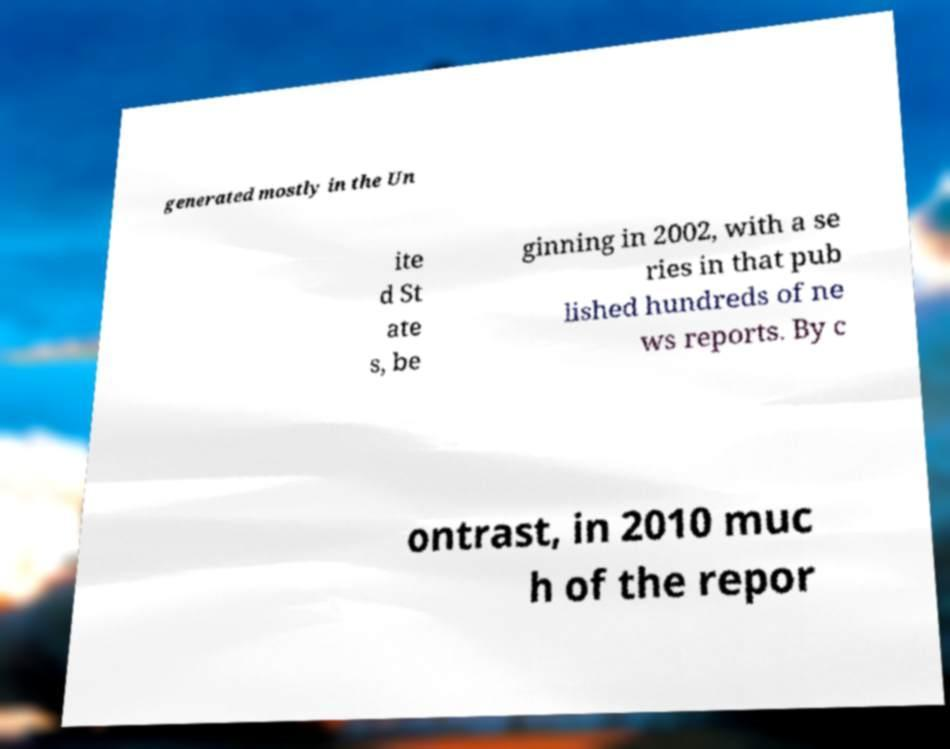Can you accurately transcribe the text from the provided image for me? generated mostly in the Un ite d St ate s, be ginning in 2002, with a se ries in that pub lished hundreds of ne ws reports. By c ontrast, in 2010 muc h of the repor 